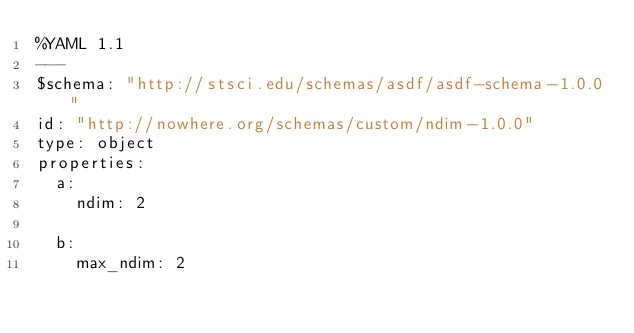<code> <loc_0><loc_0><loc_500><loc_500><_YAML_>%YAML 1.1
---
$schema: "http://stsci.edu/schemas/asdf/asdf-schema-1.0.0"
id: "http://nowhere.org/schemas/custom/ndim-1.0.0"
type: object
properties:
  a:
    ndim: 2

  b:
    max_ndim: 2</code> 